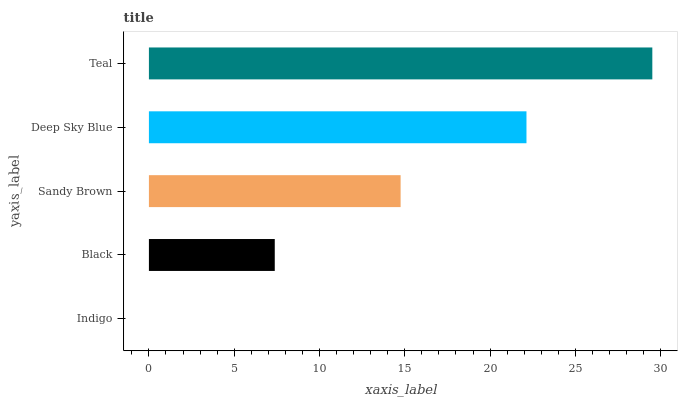Is Indigo the minimum?
Answer yes or no. Yes. Is Teal the maximum?
Answer yes or no. Yes. Is Black the minimum?
Answer yes or no. No. Is Black the maximum?
Answer yes or no. No. Is Black greater than Indigo?
Answer yes or no. Yes. Is Indigo less than Black?
Answer yes or no. Yes. Is Indigo greater than Black?
Answer yes or no. No. Is Black less than Indigo?
Answer yes or no. No. Is Sandy Brown the high median?
Answer yes or no. Yes. Is Sandy Brown the low median?
Answer yes or no. Yes. Is Black the high median?
Answer yes or no. No. Is Black the low median?
Answer yes or no. No. 